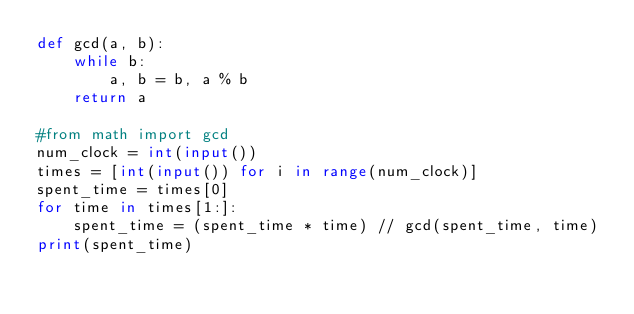Convert code to text. <code><loc_0><loc_0><loc_500><loc_500><_Python_>def gcd(a, b):
    while b:
        a, b = b, a % b
    return a

#from math import gcd
num_clock = int(input())
times = [int(input()) for i in range(num_clock)]
spent_time = times[0]
for time in times[1:]:
    spent_time = (spent_time * time) // gcd(spent_time, time)
print(spent_time)</code> 